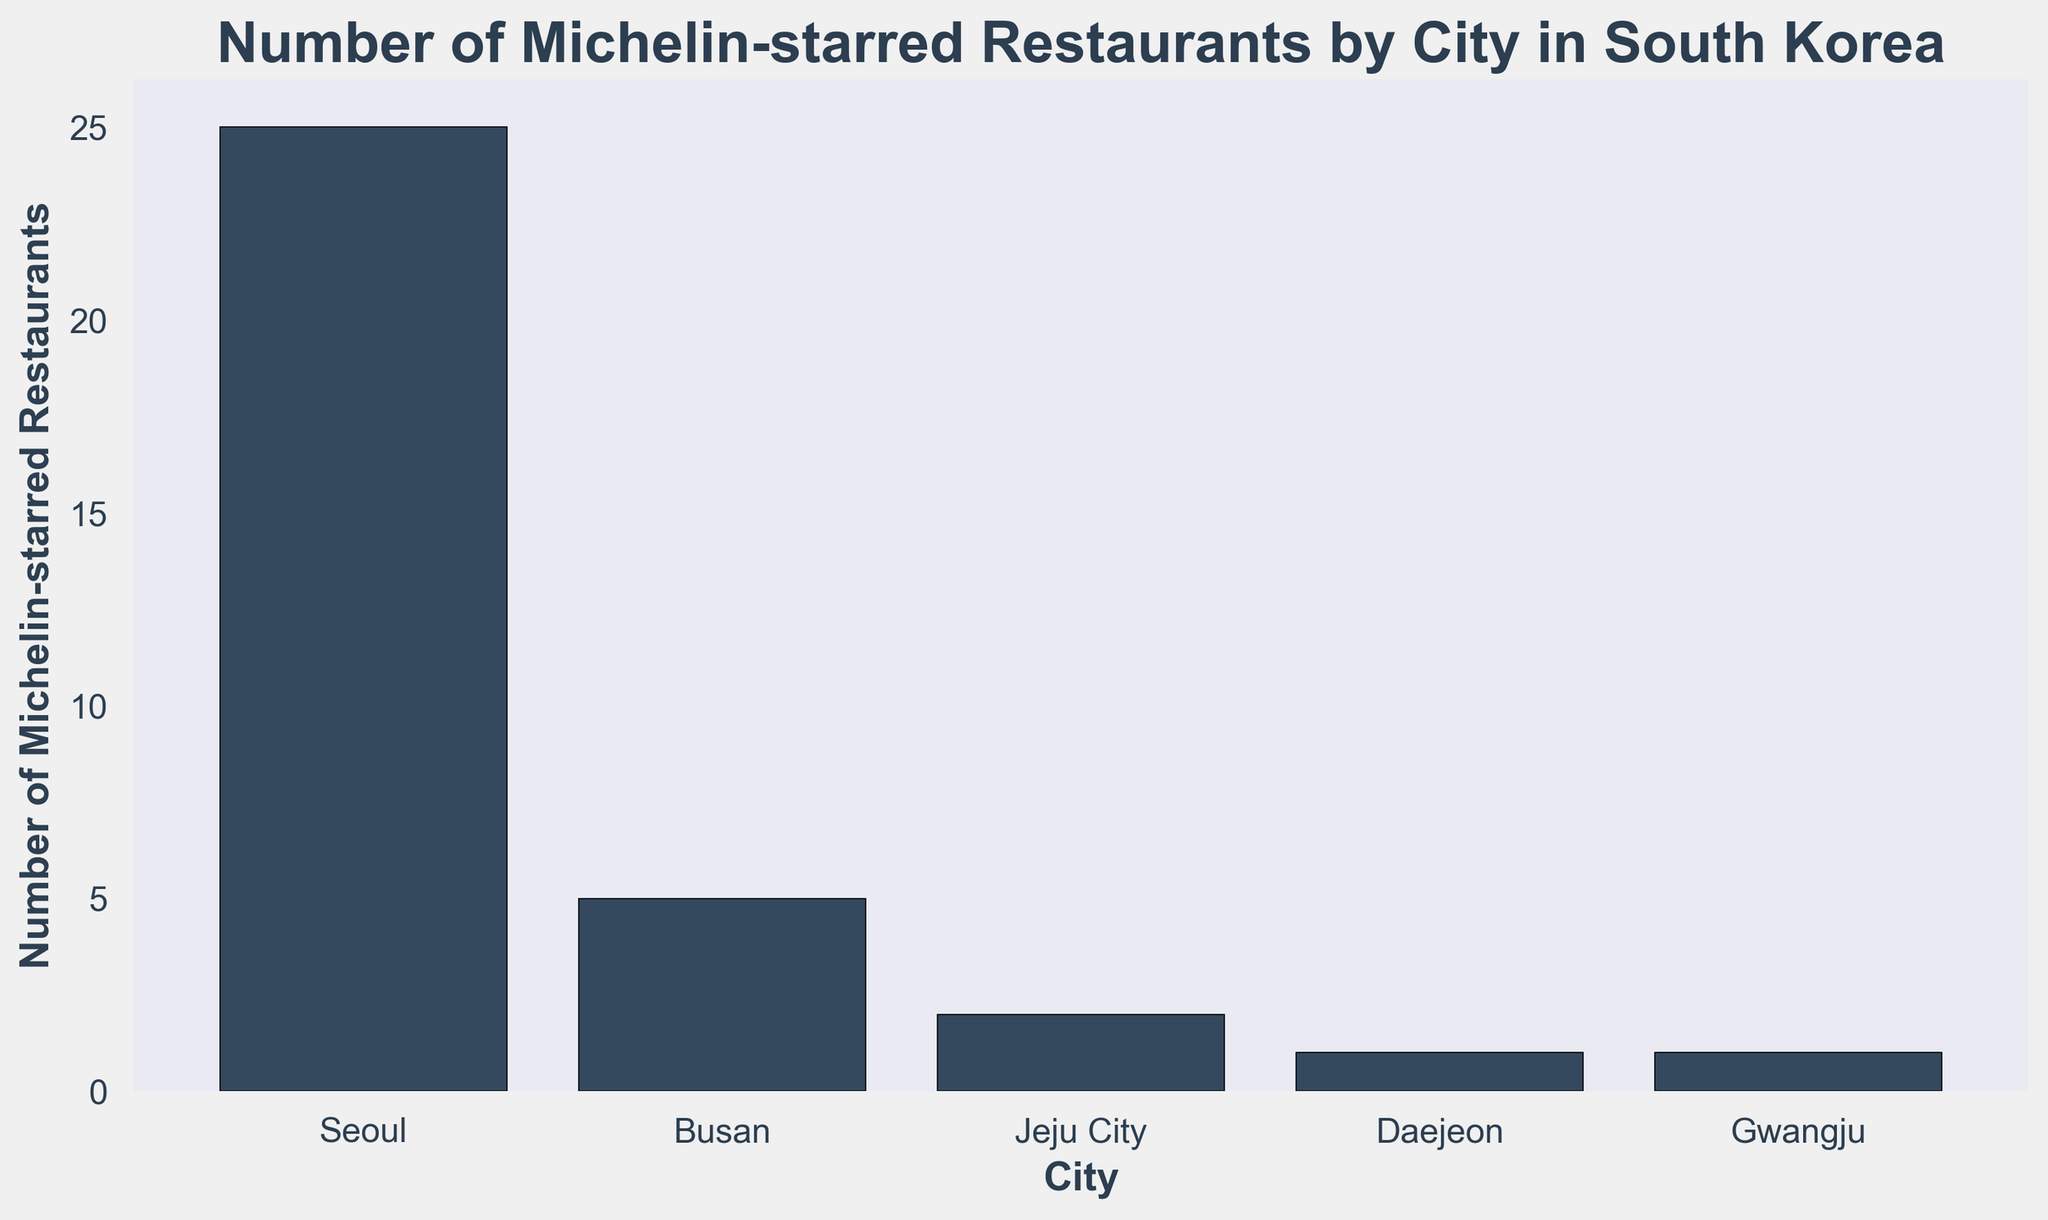Which city has the highest number of Michelin-starred restaurants? From the bar chart, we see that the tallest bar represents Seoul. Comparing the heights of all bars, none of the other cities have a taller bar than Seoul.
Answer: Seoul How many Michelin-starred restaurants are there in total across all cities? Adding up all the values from the bars: 25 (Seoul) + 5 (Busan) + 2 (Jeju City) + 1 (Daejeon) + 1 (Gwangju) = 34
Answer: 34 Which two cities have the same number of Michelin-starred restaurants? From the bar chart, the bars for Daejeon and Gwangju have the same height, representing the same number of restaurants.
Answer: Daejeon and Gwangju What is the difference in the number of Michelin-starred restaurants between Seoul and Busan? Subtracting the number of restaurants in Busan from that in Seoul: 25 (Seoul) - 5 (Busan) = 20
Answer: 20 What is the average number of Michelin-starred restaurants per city? First, find the total number of restaurants: 25 (Seoul) + 5 (Busan) + 2 (Jeju City) + 1 (Daejeon) + 1 (Gwangju) = 34. Then divide by the number of cities: 34 / 5 = 6.8
Answer: 6.8 If you combine the number of Michelin-starred restaurants in Daejeon and Gwangju, how many do you get? Adding the number of restaurants in Daejeon and Gwangju: 1 (Daejeon) + 1 (Gwangju) = 2
Answer: 2 